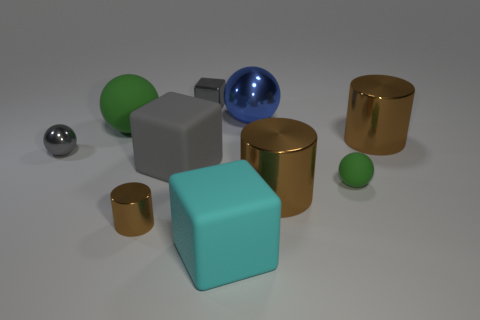Subtract all big cyan cubes. How many cubes are left? 2 Subtract 1 cylinders. How many cylinders are left? 2 Subtract all gray spheres. How many spheres are left? 3 Subtract all cubes. How many objects are left? 7 Subtract all green cylinders. How many gray blocks are left? 2 Subtract 0 green cylinders. How many objects are left? 10 Subtract all yellow cubes. Subtract all green cylinders. How many cubes are left? 3 Subtract all big cylinders. Subtract all tiny gray things. How many objects are left? 6 Add 8 small green rubber spheres. How many small green rubber spheres are left? 9 Add 1 big red matte blocks. How many big red matte blocks exist? 1 